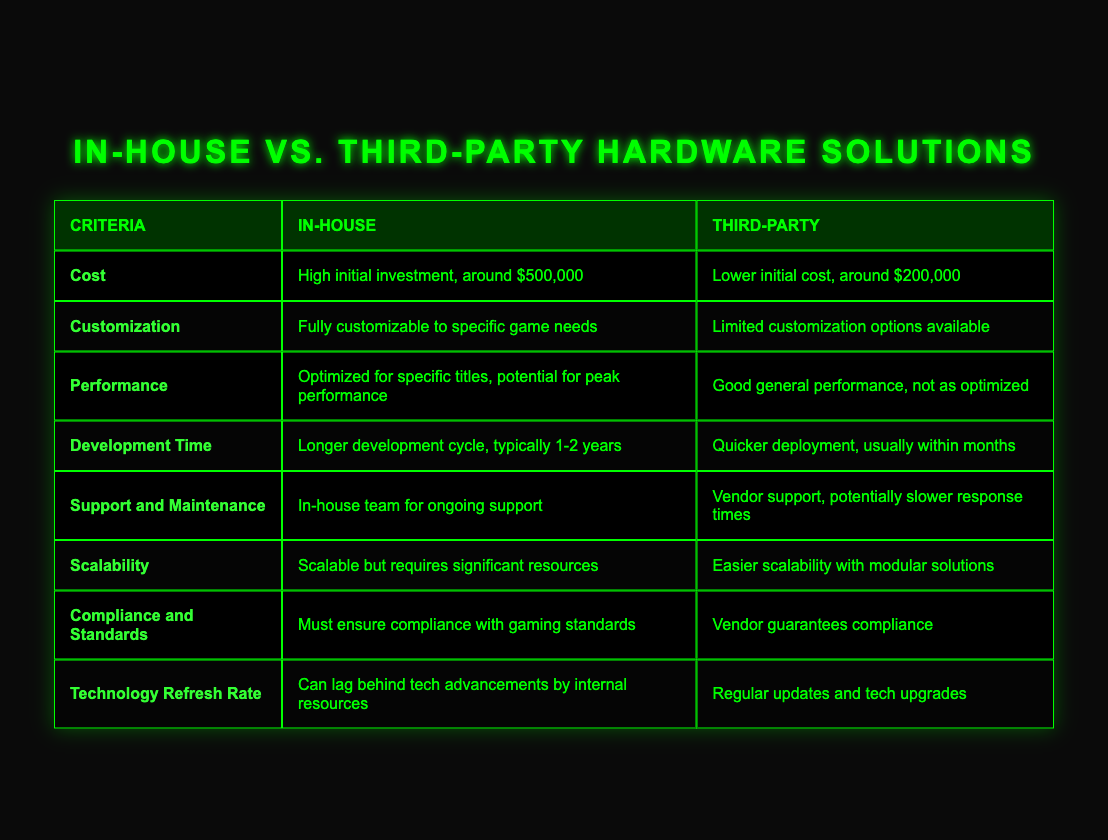What is the cost of the in-house solution? The table directly states that the cost of the in-house solution is high, with an initial investment of around $500,000.
Answer: $500,000 How long is the development cycle for the in-house solution? According to the table, the in-house development cycle is longer, typically taking 1-2 years.
Answer: 1-2 years Is third-party hardware easier to scale? The table notes that third-party hardware offers easier scalability with modular solutions, implying that it is indeed easier to scale.
Answer: Yes What is the performance difference between in-house and third-party solutions? The table describes that the in-house solution is optimized for specific titles, leading to potential peak performance, while the third-party solution provides good general performance but is not as optimized.
Answer: In-house is better optimized What would be the total cost difference between in-house and third-party solutions? The in-house solution costs $500,000 and the third-party solution costs $200,000. The difference can be calculated as $500,000 - $200,000 = $300,000.
Answer: $300,000 Are the customization options for third-party hardware limited? The table explicitly states that the third-party hardware has limited customization options available.
Answer: Yes Which solution guarantees compliance with gaming standards? The table indicates that the vendor of the third-party solution guarantees compliance, while in-house must ensure its own compliance.
Answer: Third-party solution What are the implications of the technology refresh rate for both solutions? The in-house solution can lag behind tech advancements due to internal resources, while the third-party solution benefits from regular updates and tech upgrades. This suggests that the third-party solution might be more up-to-date with technology.
Answer: Third-party is more up-to-date If a company requires full customization, which solution should they choose? The in-house solution is fully customizable to specific game needs, making it the better choice for companies requiring this feature.
Answer: In-house solution Considering support and maintenance, which option may provide quicker responses? The table indicates that while in-house provides ongoing team support, third-party vendor support may have slower response times, suggesting that in-house might offer quicker responses.
Answer: In-house may provide quicker responses 